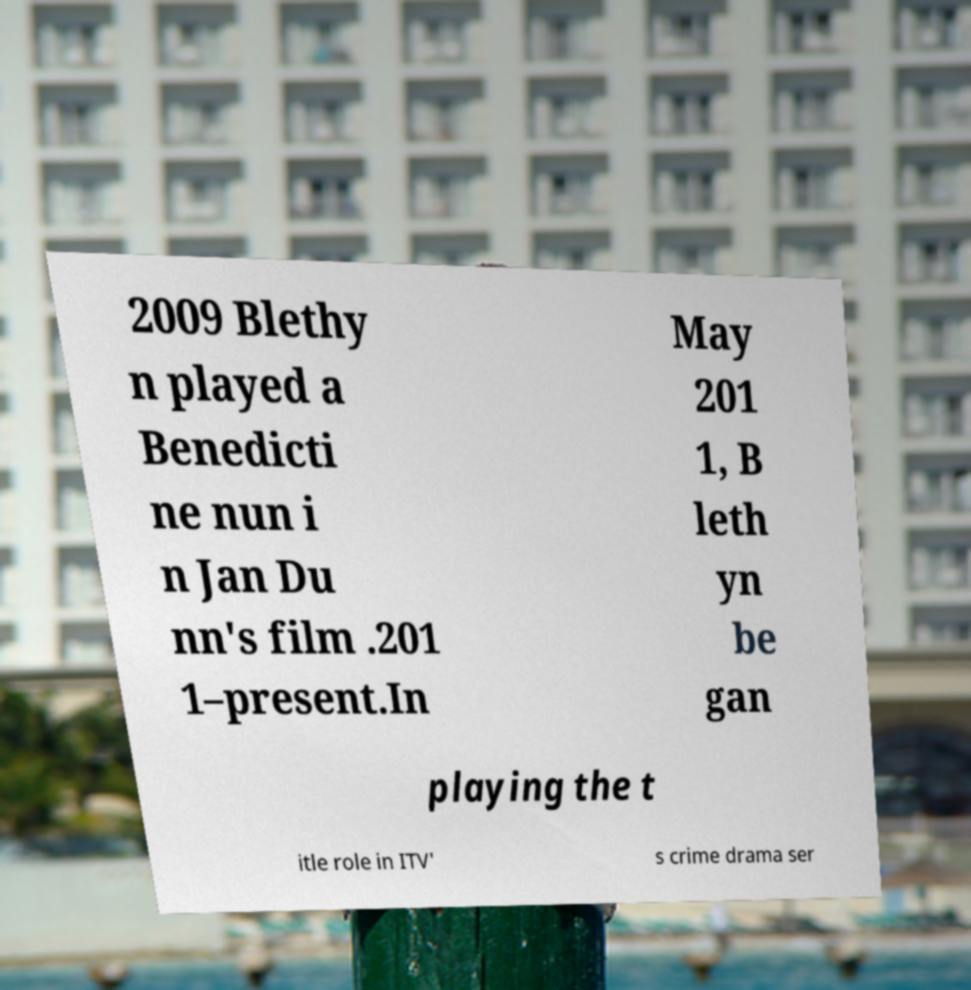For documentation purposes, I need the text within this image transcribed. Could you provide that? 2009 Blethy n played a Benedicti ne nun i n Jan Du nn's film .201 1–present.In May 201 1, B leth yn be gan playing the t itle role in ITV' s crime drama ser 